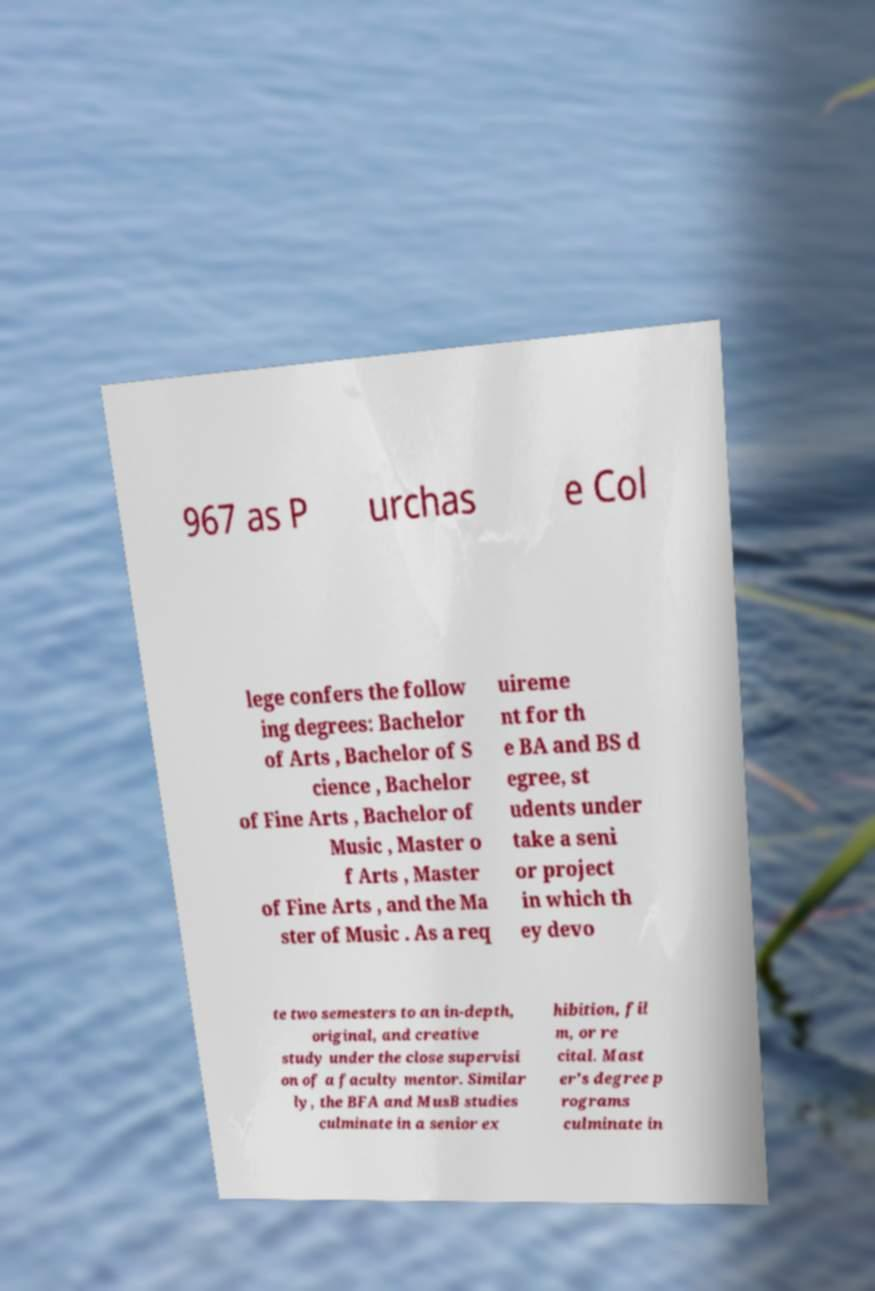Please read and relay the text visible in this image. What does it say? 967 as P urchas e Col lege confers the follow ing degrees: Bachelor of Arts , Bachelor of S cience , Bachelor of Fine Arts , Bachelor of Music , Master o f Arts , Master of Fine Arts , and the Ma ster of Music . As a req uireme nt for th e BA and BS d egree, st udents under take a seni or project in which th ey devo te two semesters to an in-depth, original, and creative study under the close supervisi on of a faculty mentor. Similar ly, the BFA and MusB studies culminate in a senior ex hibition, fil m, or re cital. Mast er's degree p rograms culminate in 